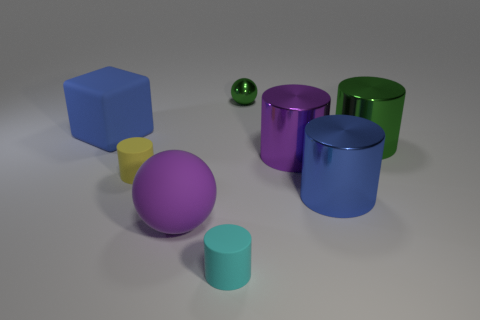There is a large rubber object in front of the large blue thing that is behind the purple cylinder; are there any tiny cylinders that are on the right side of it?
Provide a short and direct response. Yes. Are the small ball and the large green cylinder made of the same material?
Make the answer very short. Yes. Are there any other things that are the same shape as the cyan rubber thing?
Offer a very short reply. Yes. The big purple object left of the ball that is behind the blue block is made of what material?
Offer a terse response. Rubber. How big is the blue thing that is in front of the blue cube?
Provide a succinct answer. Large. What is the color of the thing that is behind the green shiny cylinder and left of the small cyan object?
Your response must be concise. Blue. Do the shiny cylinder in front of the yellow rubber object and the big rubber block have the same size?
Ensure brevity in your answer.  Yes. Are there any large rubber cubes left of the big cylinder that is left of the large blue cylinder?
Your answer should be compact. Yes. What is the material of the blue cube?
Your answer should be very brief. Rubber. Are there any tiny cyan cylinders to the left of the large blue matte object?
Give a very brief answer. No. 